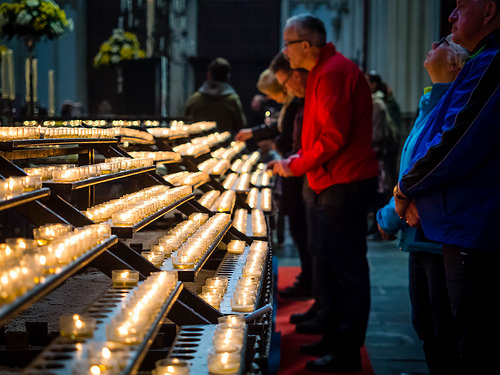<image>
Can you confirm if the candles is next to the person? Yes. The candles is positioned adjacent to the person, located nearby in the same general area. Is the man on the man? No. The man is not positioned on the man. They may be near each other, but the man is not supported by or resting on top of the man. 